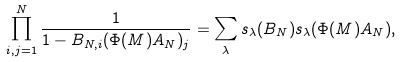<formula> <loc_0><loc_0><loc_500><loc_500>\prod _ { i , j = 1 } ^ { N } \frac { 1 } { 1 - B _ { N , i } ( \Phi ( M ) A _ { N } ) _ { j } } = \sum _ { \lambda } s _ { \lambda } ( B _ { N } ) s _ { \lambda } ( \Phi ( M ) A _ { N } ) ,</formula> 